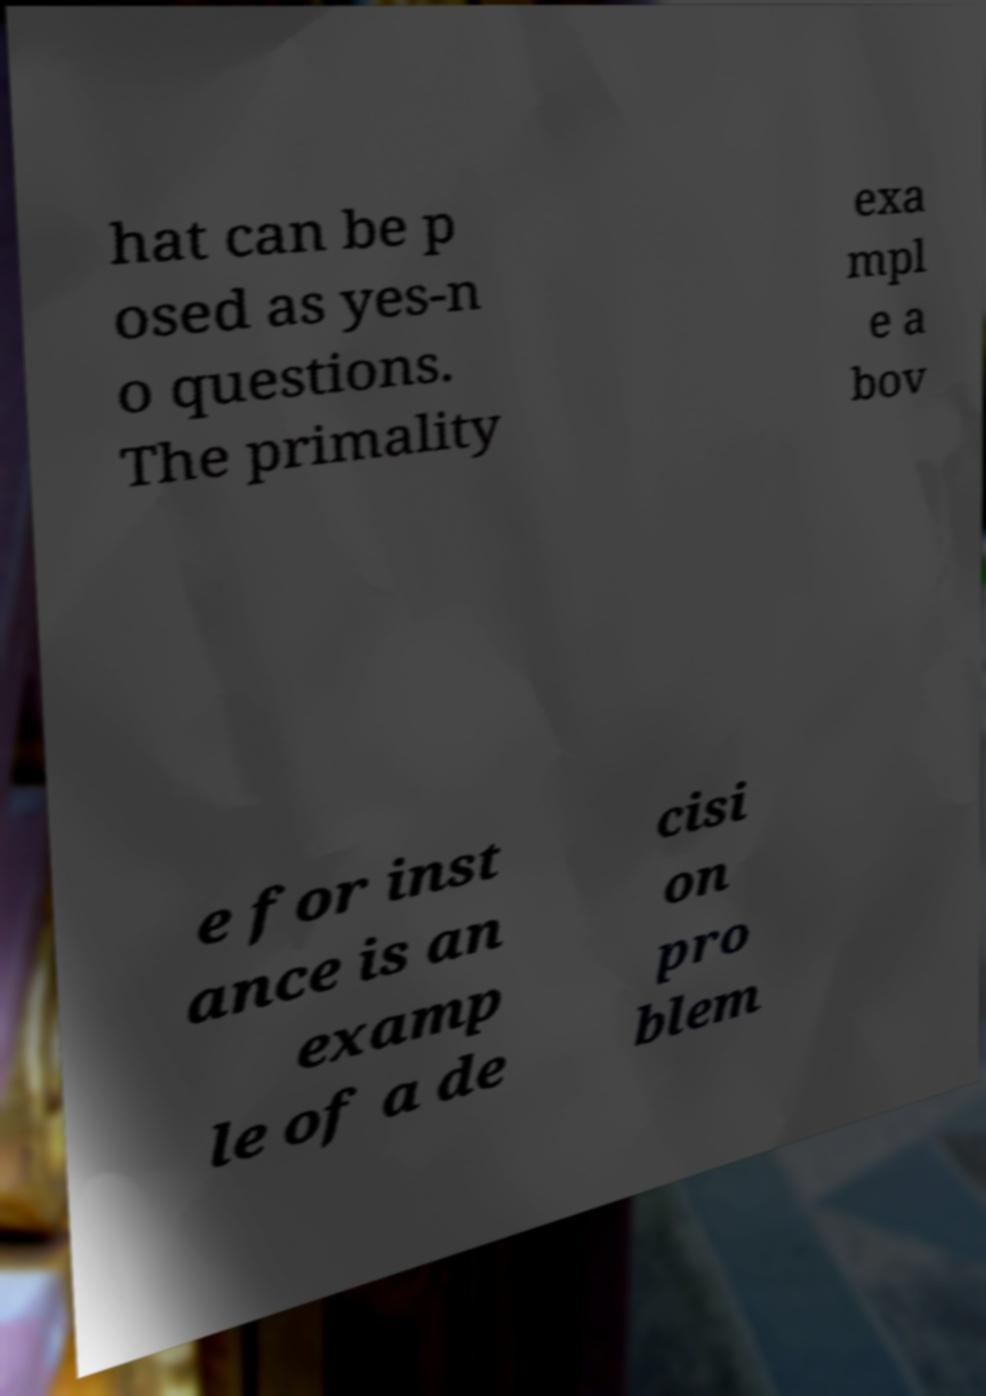Please identify and transcribe the text found in this image. hat can be p osed as yes-n o questions. The primality exa mpl e a bov e for inst ance is an examp le of a de cisi on pro blem 